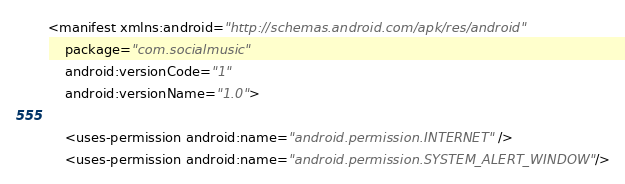<code> <loc_0><loc_0><loc_500><loc_500><_XML_><manifest xmlns:android="http://schemas.android.com/apk/res/android"
    package="com.socialmusic"
    android:versionCode="1"
    android:versionName="1.0">

    <uses-permission android:name="android.permission.INTERNET" />
    <uses-permission android:name="android.permission.SYSTEM_ALERT_WINDOW"/>
</code> 